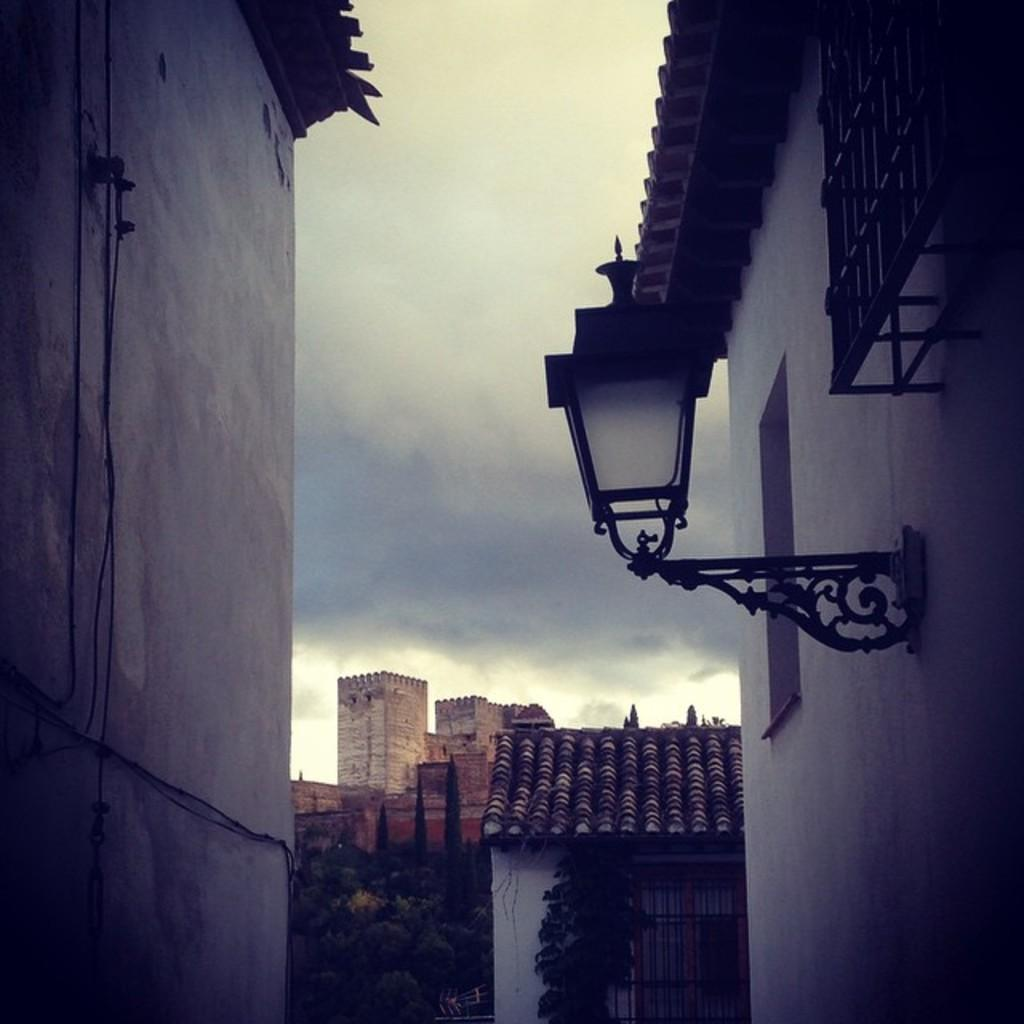What can be seen in the background of the image? There are buildings and trees in the background of the image. What structures are present on both sides of the image? The walls of a building are present on both sides of the image. What is visible at the top of the image? The sky is visible at the top of the image. How many boys are wearing skirts in the image? There are no boys or skirts present in the image. What type of maid is visible in the image? There is no maid present in the image. 